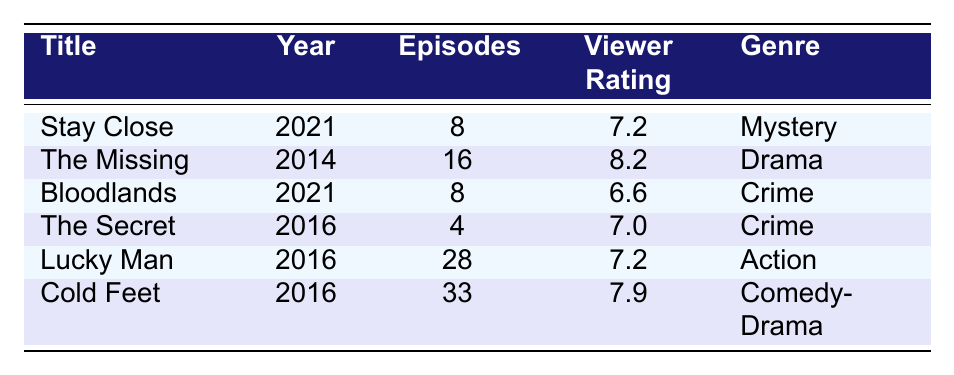What is the viewer rating of "The Missing"? The table lists "The Missing" with a viewer rating of 8.2.
Answer: 8.2 How many episodes does "Stay Close" have? "Stay Close" is shown to have 8 episodes in the table.
Answer: 8 episodes Which series has the highest viewer rating? By comparing the viewer ratings in the table, "The Missing" has the highest rating at 8.2.
Answer: The Missing Is "Bloodlands" a comedy-drama series? The genre listed for "Bloodlands" is "Crime," so it is not a comedy-drama.
Answer: No What is the average viewer rating of all shows listed? The viewer ratings are 7.2, 8.2, 6.6, 7.0, 7.2, and 7.9. Summing these gives 43.1. There are 6 shows, so the average is 43.1 / 6 = 7.1833, rounded to 7.2.
Answer: 7.2 What is the total number of episodes across all series? The total number of episodes is calculated by adding: 8 + 16 + 8 + 4 + 28 + 33 = 97.
Answer: 97 episodes How many series were released in 2021? The table lists "Stay Close" and "Bloodlands" as having a release year of 2021, making it a total of 2 series.
Answer: 2 series Which series has the largest number of episodes? Looking at the episode counts in the table, "Cold Feet" has 33 episodes, which is the highest.
Answer: Cold Feet Are there any series with a viewer rating lower than 7.0? Yes, "Bloodlands" has a viewer rating of 6.6, which is below 7.0.
Answer: Yes What is the genre of "Lucky Man"? The table indicates that "Lucky Man" belongs to the "Action" genre.
Answer: Action 